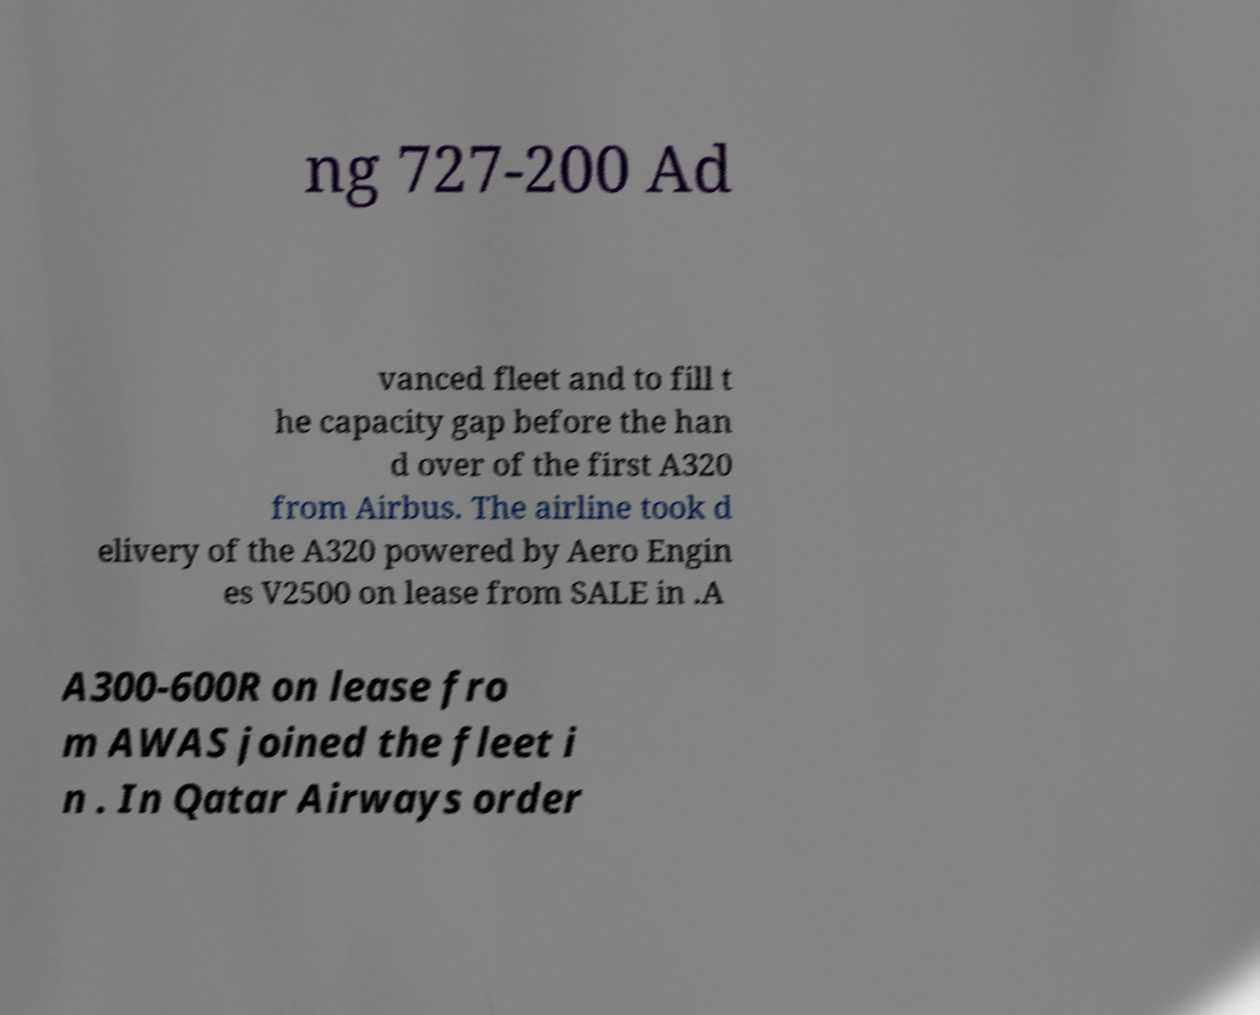Please read and relay the text visible in this image. What does it say? ng 727-200 Ad vanced fleet and to fill t he capacity gap before the han d over of the first A320 from Airbus. The airline took d elivery of the A320 powered by Aero Engin es V2500 on lease from SALE in .A A300-600R on lease fro m AWAS joined the fleet i n . In Qatar Airways order 